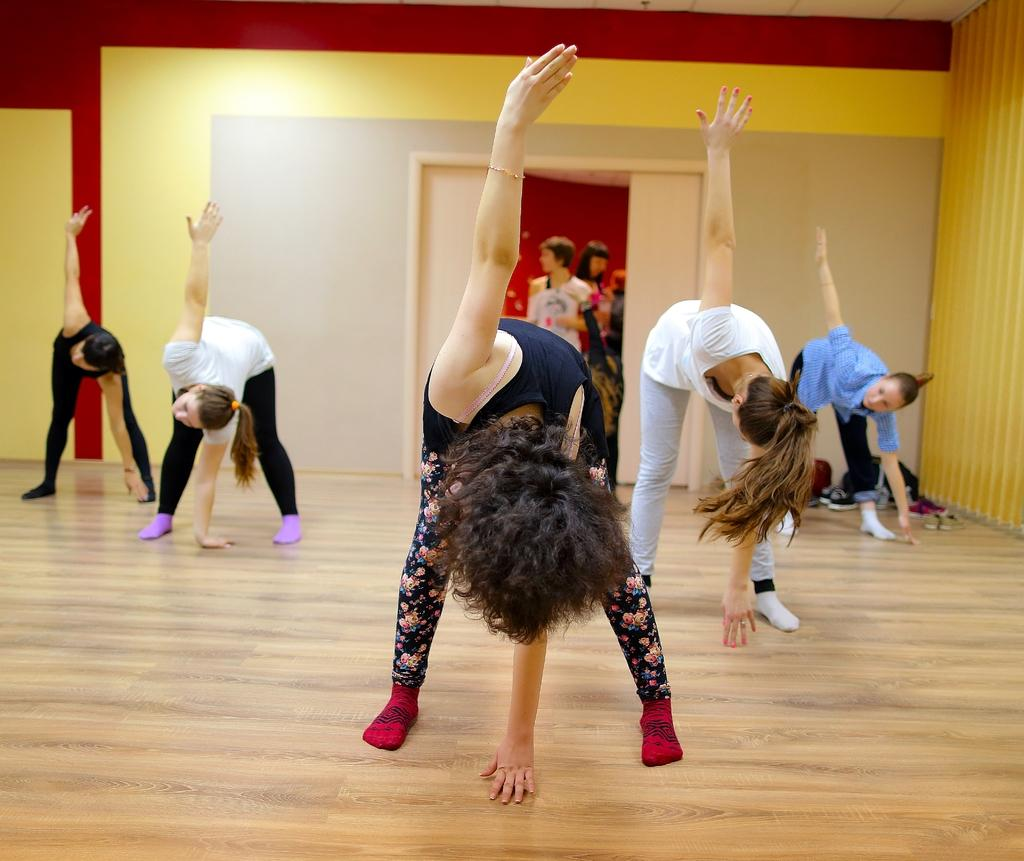What are the persons in the image doing? The persons in the image are doing exercise. Where are the persons exercising? They are exercising in front of a wall. Are there any other persons visible in the image? Yes, there are persons standing in front of a door. What type of silk material is being used by the writer in the image? There is no writer or silk material present in the image. 